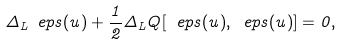<formula> <loc_0><loc_0><loc_500><loc_500>\Delta _ { L } \ e p s ( u ) + \frac { 1 } { 2 } \Delta _ { L } Q [ \ e p s ( u ) , \ e p s ( u ) ] = 0 ,</formula> 